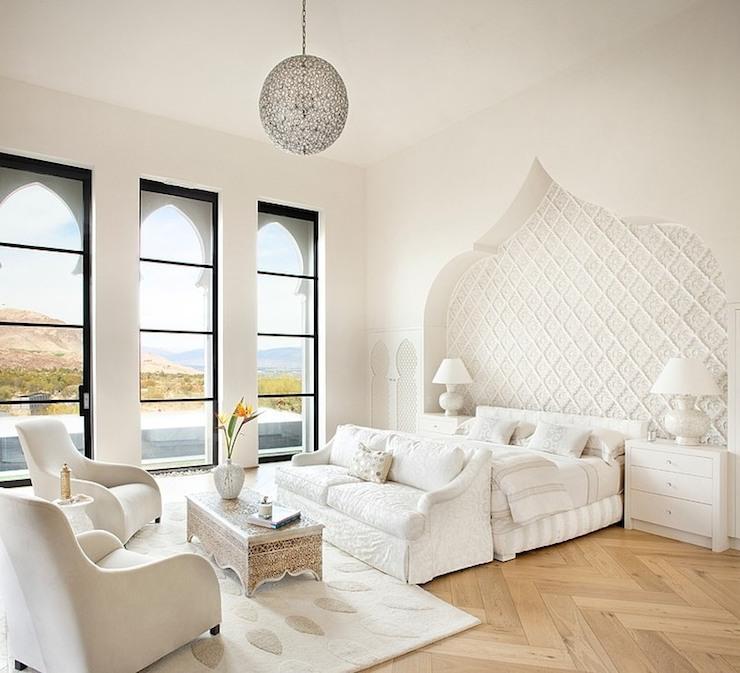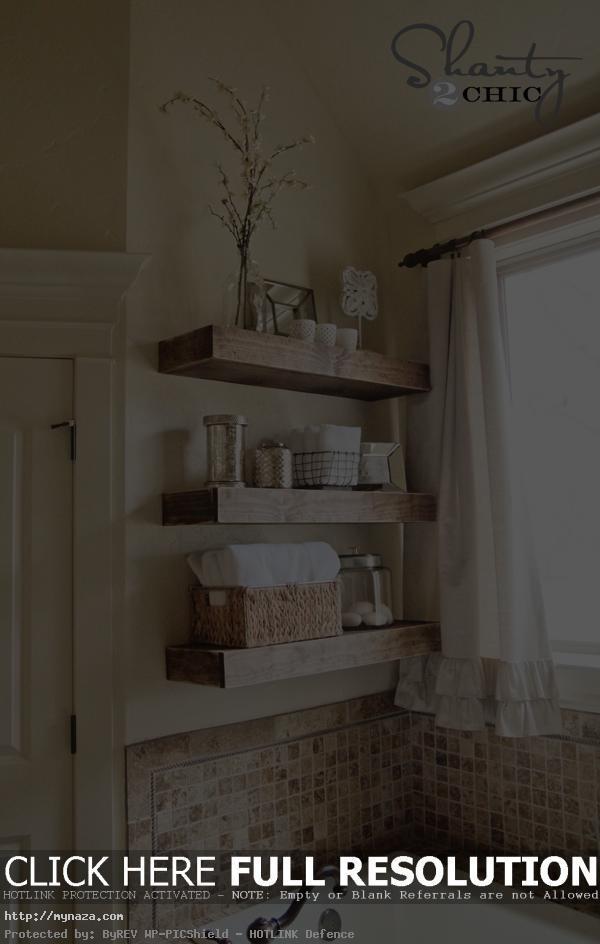The first image is the image on the left, the second image is the image on the right. For the images displayed, is the sentence "The outside can be seen in the image on the left." factually correct? Answer yes or no. Yes. The first image is the image on the left, the second image is the image on the right. Examine the images to the left and right. Is the description "A porcelain pitcher is shown by something made of fabric in one image." accurate? Answer yes or no. No. 